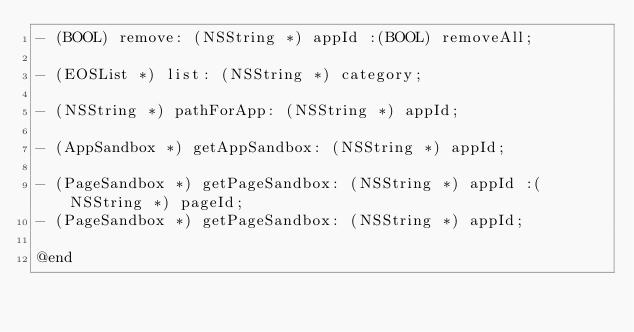<code> <loc_0><loc_0><loc_500><loc_500><_C_>- (BOOL) remove: (NSString *) appId :(BOOL) removeAll;

- (EOSList *) list: (NSString *) category;

- (NSString *) pathForApp: (NSString *) appId;

- (AppSandbox *) getAppSandbox: (NSString *) appId;

- (PageSandbox *) getPageSandbox: (NSString *) appId :(NSString *) pageId;
- (PageSandbox *) getPageSandbox: (NSString *) appId;

@end
</code> 